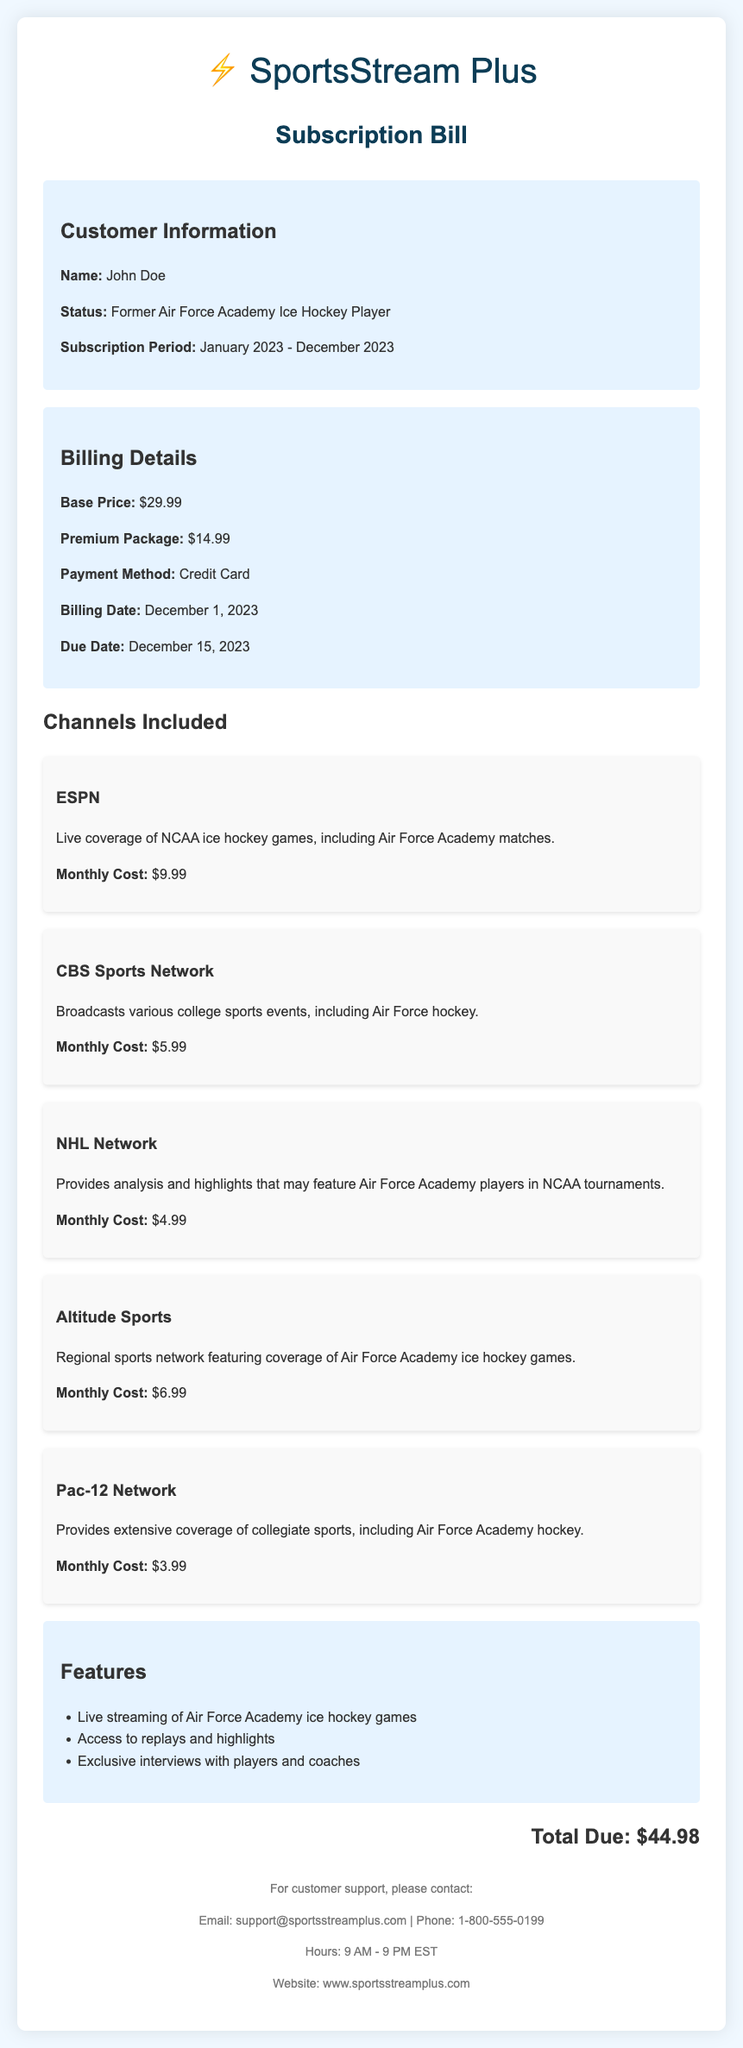What is the base price of the subscription? The base price is listed under the billing details section of the document.
Answer: $29.99 How many channels are included in the subscription? The channels are listed in a section dedicated to the channels included in the subscription.
Answer: 5 What is the monthly cost of ESPN? The monthly cost of ESPN is specified next to the channel description.
Answer: $9.99 What is the total due amount for the subscription? The total amount is mentioned at the end of the document in the total section.
Answer: $44.98 What payment method is used for the subscription? The payment method is stated in the billing details section.
Answer: Credit Card When is the billing date? The billing date is provided in the billing details section of the document.
Answer: December 1, 2023 Which channel provides analysis and highlights of NCAA tournaments? The channel providing analysis and highlights is mentioned in the description of one of the channels.
Answer: NHL Network What features are available with the subscription? Features are listed in a specific section dedicated to subscription features.
Answer: Live streaming of Air Force Academy ice hockey games, Access to replays and highlights, Exclusive interviews with players and coaches What is the customer's status? The customer's status is detailed in the customer information section of the document.
Answer: Former Air Force Academy Ice Hockey Player 